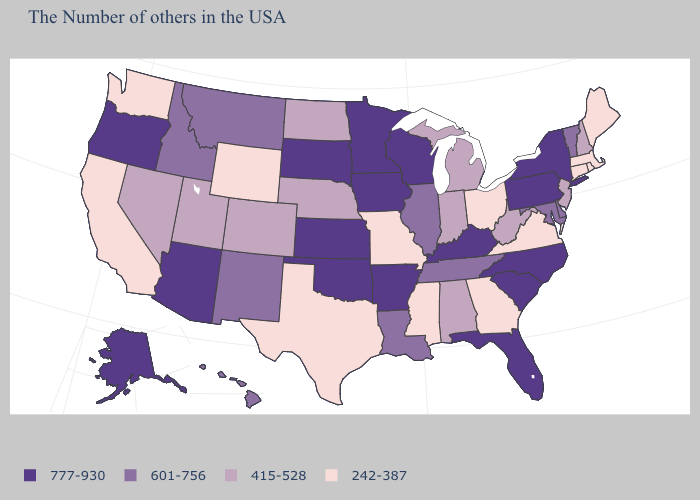Name the states that have a value in the range 242-387?
Be succinct. Maine, Massachusetts, Rhode Island, Connecticut, Virginia, Ohio, Georgia, Mississippi, Missouri, Texas, Wyoming, California, Washington. Among the states that border Nevada , which have the lowest value?
Quick response, please. California. Which states have the lowest value in the Northeast?
Short answer required. Maine, Massachusetts, Rhode Island, Connecticut. What is the value of Pennsylvania?
Short answer required. 777-930. Is the legend a continuous bar?
Keep it brief. No. Name the states that have a value in the range 777-930?
Write a very short answer. New York, Pennsylvania, North Carolina, South Carolina, Florida, Kentucky, Wisconsin, Arkansas, Minnesota, Iowa, Kansas, Oklahoma, South Dakota, Arizona, Oregon, Alaska. Name the states that have a value in the range 601-756?
Short answer required. Vermont, Delaware, Maryland, Tennessee, Illinois, Louisiana, New Mexico, Montana, Idaho, Hawaii. What is the lowest value in the Northeast?
Short answer required. 242-387. What is the value of New Mexico?
Keep it brief. 601-756. Name the states that have a value in the range 415-528?
Quick response, please. New Hampshire, New Jersey, West Virginia, Michigan, Indiana, Alabama, Nebraska, North Dakota, Colorado, Utah, Nevada. Among the states that border Vermont , does New York have the lowest value?
Concise answer only. No. Does the first symbol in the legend represent the smallest category?
Short answer required. No. What is the highest value in states that border Colorado?
Give a very brief answer. 777-930. Which states have the lowest value in the USA?
Quick response, please. Maine, Massachusetts, Rhode Island, Connecticut, Virginia, Ohio, Georgia, Mississippi, Missouri, Texas, Wyoming, California, Washington. 